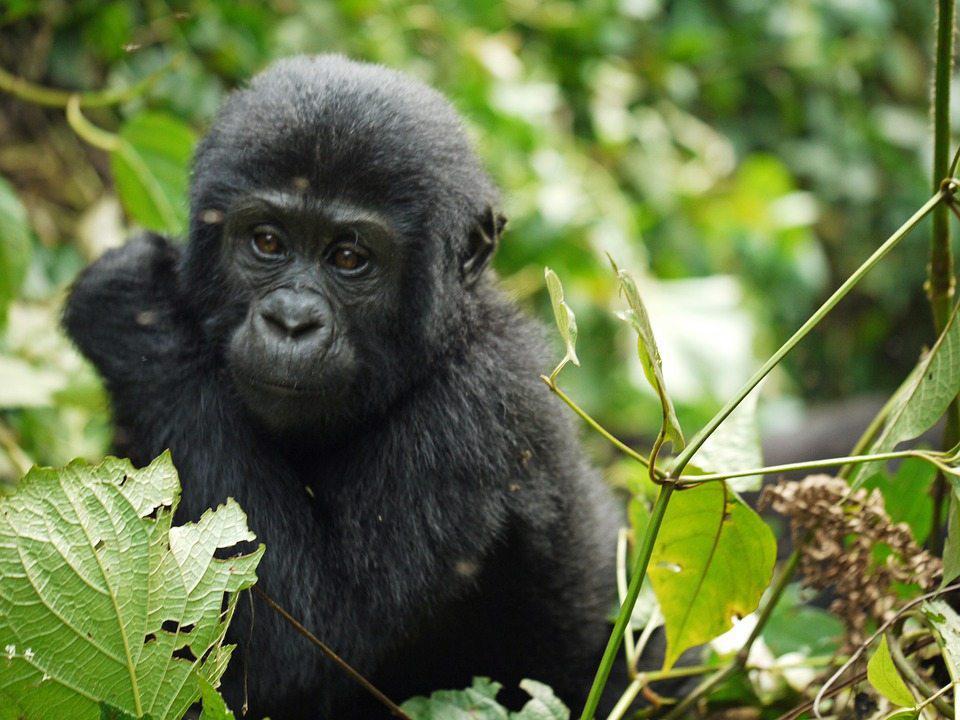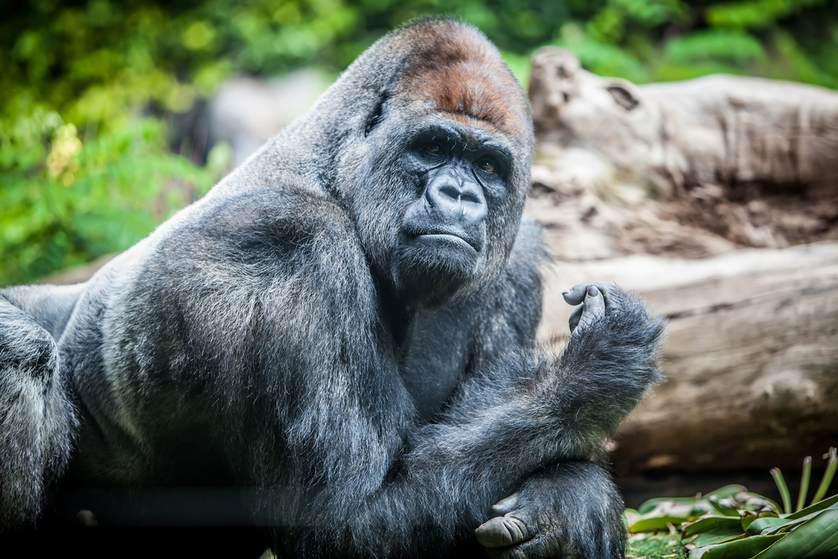The first image is the image on the left, the second image is the image on the right. For the images displayed, is the sentence "There are three gorillas" factually correct? Answer yes or no. No. 